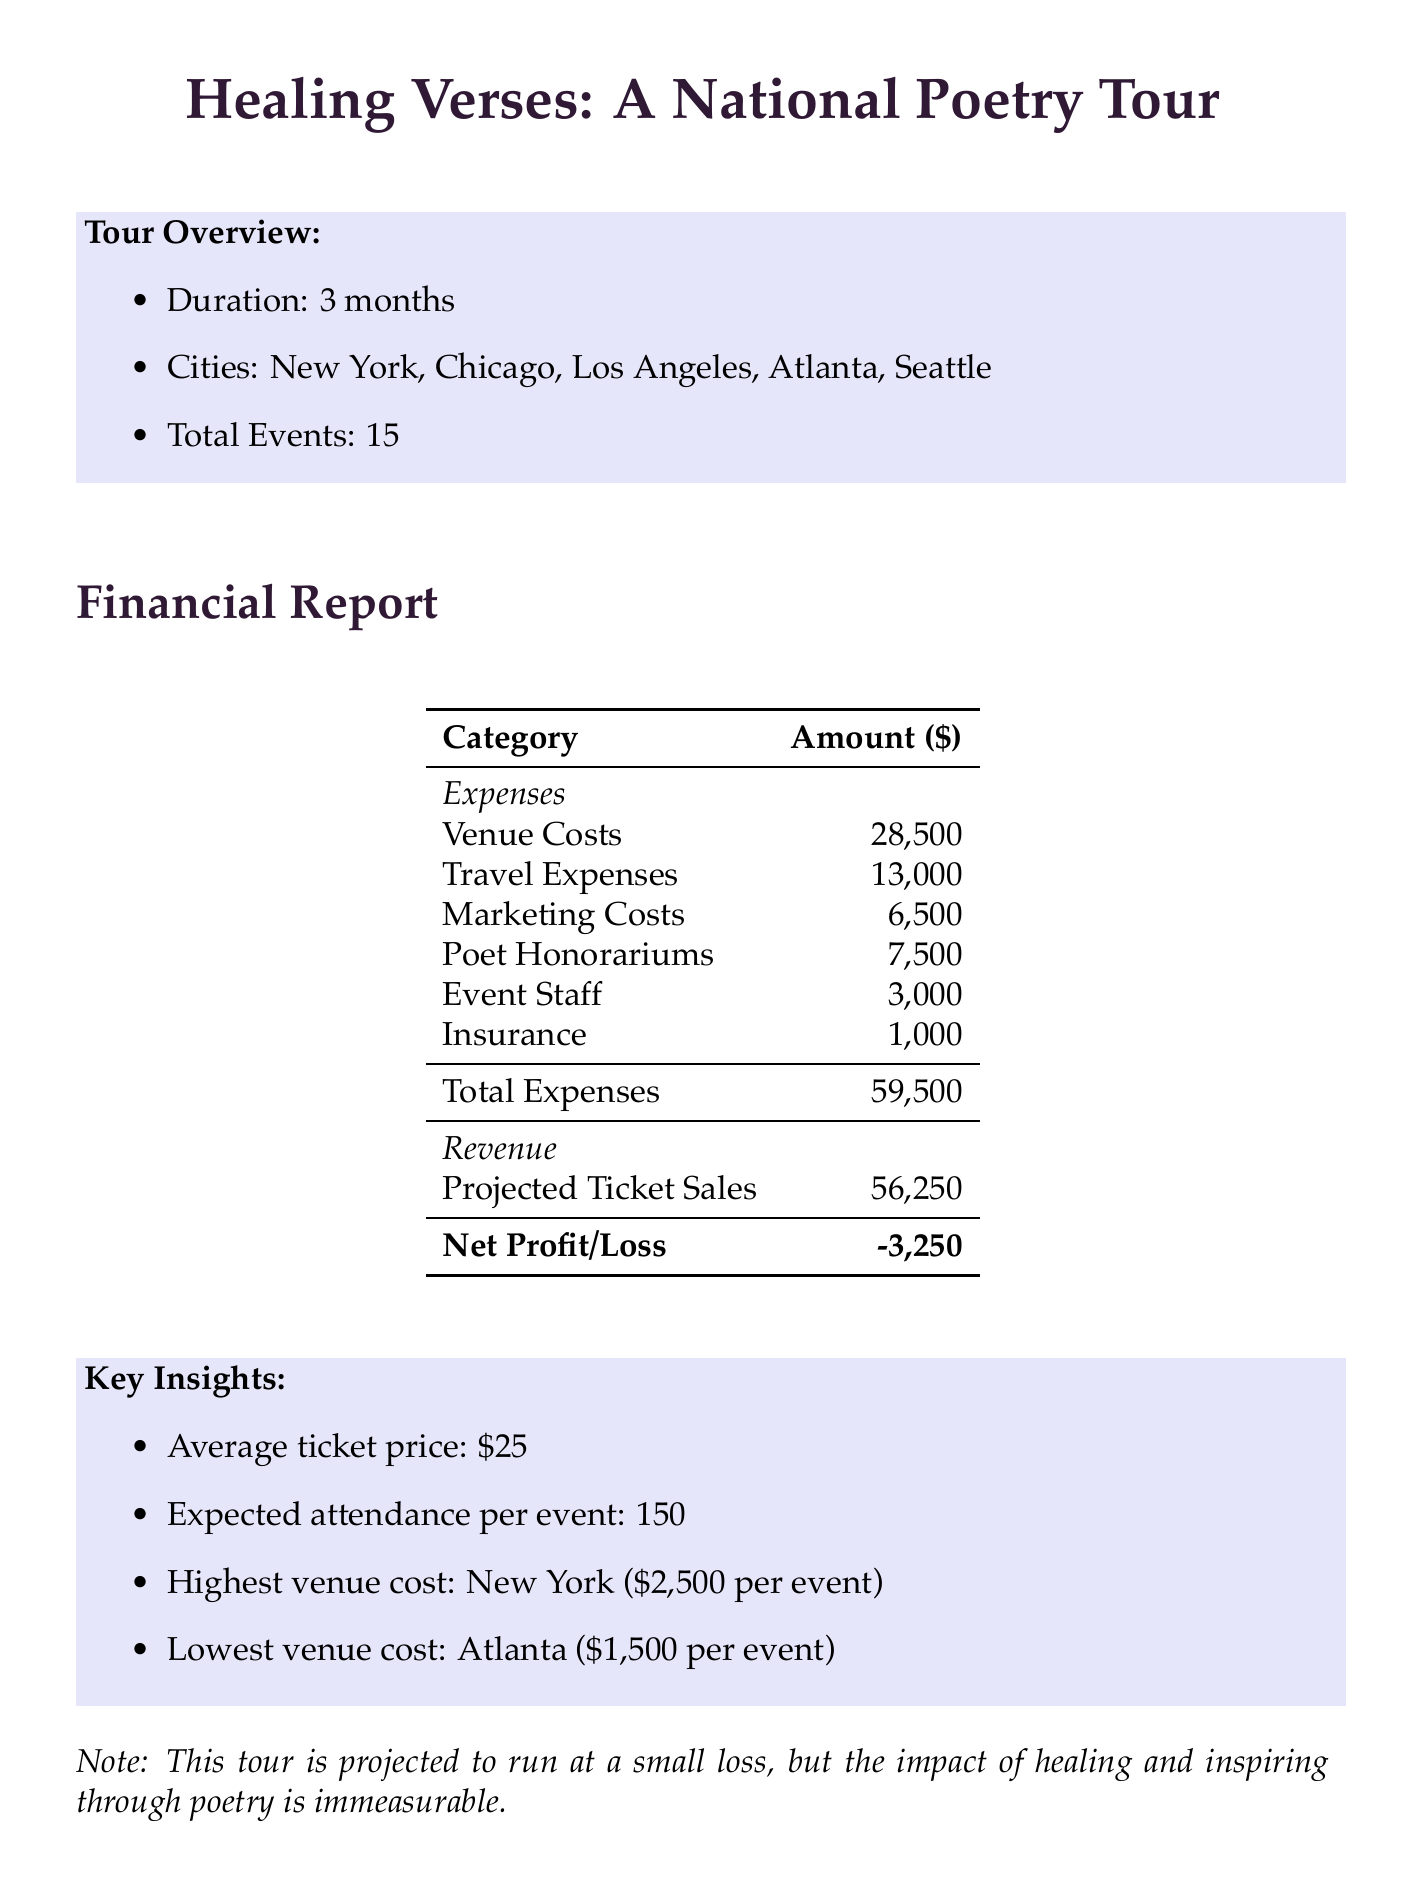what is the name of the tour? The name of the tour is mentioned in the document as "Healing Verses: A National Poetry Tour."
Answer: Healing Verses: A National Poetry Tour how many total events are planned? The document states that there are a total of 15 events planned for the tour.
Answer: 15 what is the cost per event in New York? The venue cost for the event in New York is specified as $2500 per event.
Answer: 2500 what is the total projected revenue from ticket sales? The document provides the projected ticket sales revenue as $56250.
Answer: 56250 what are the total venue costs? The total venue costs are calculated in the document as $28500.
Answer: 28500 how much is allocated for poet honorariums? The document details that $7500 is allocated for poet honorariums.
Answer: 7500 what is the highest venue cost? According to the document, the highest venue cost is for New York at $2500 per event.
Answer: New York ($2500) what are the total travel expenses? The document totals the travel expenses at $13000.
Answer: 13000 what is the expected attendance per event? The expected attendance per event is mentioned as 150 in the document.
Answer: 150 